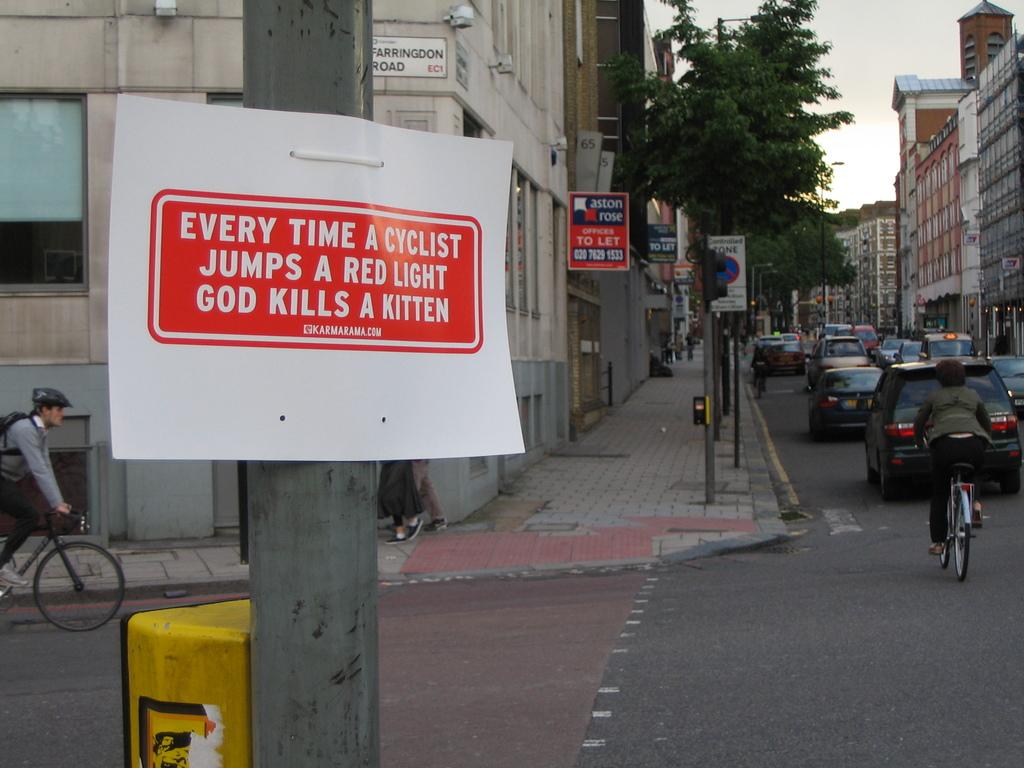What does god kill?
Make the answer very short. A kitten. 